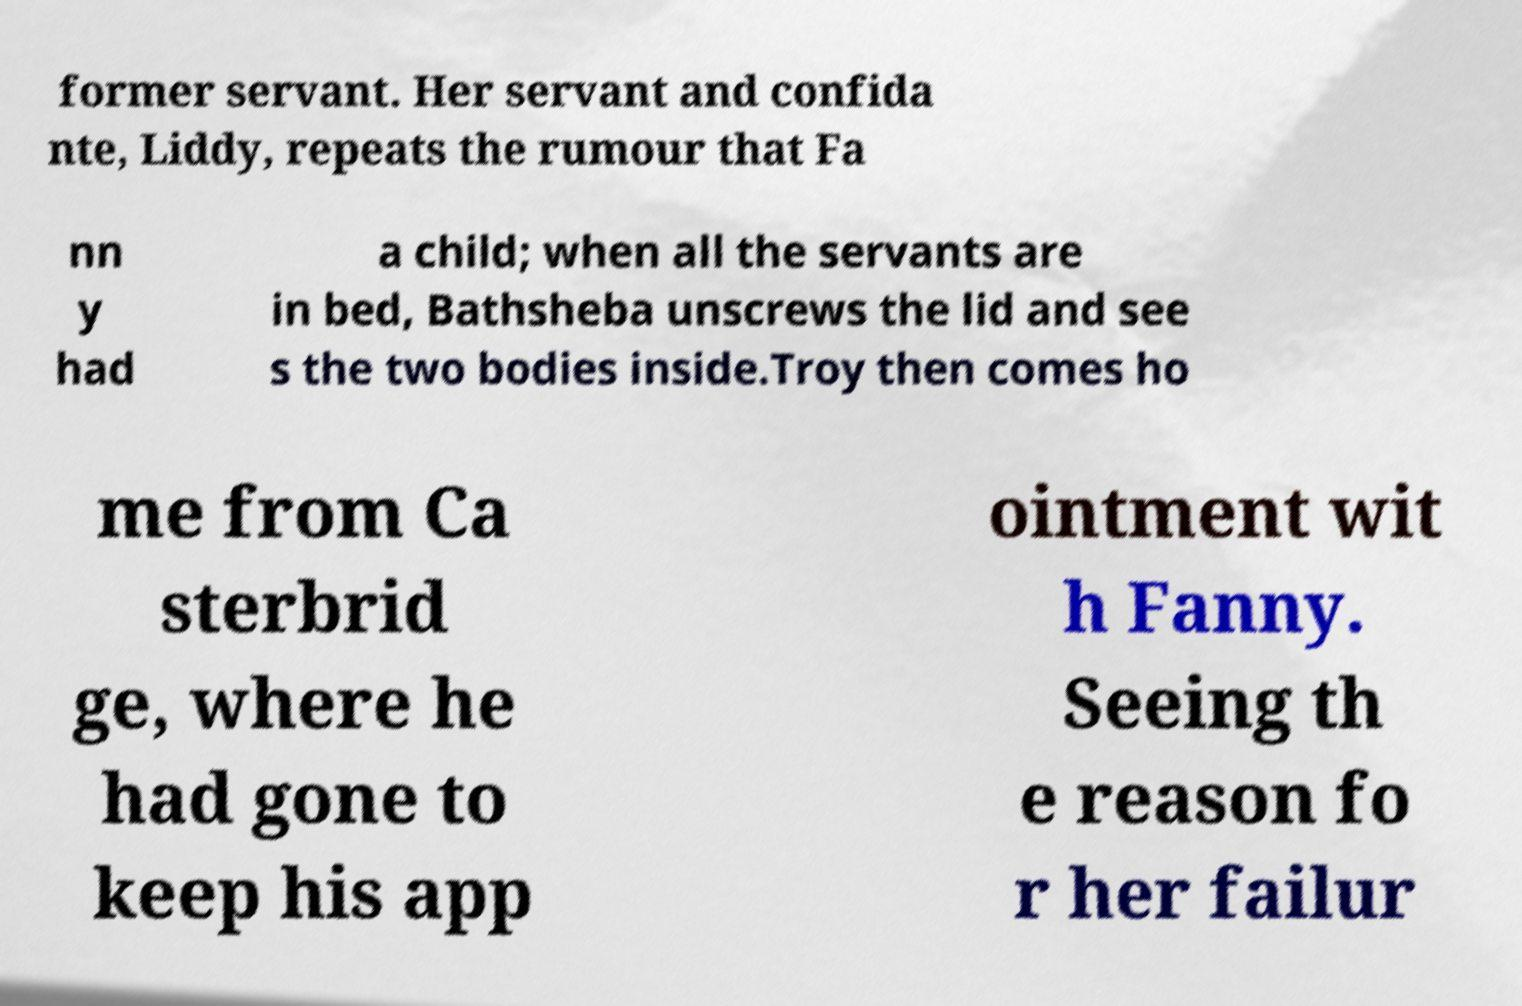Can you accurately transcribe the text from the provided image for me? former servant. Her servant and confida nte, Liddy, repeats the rumour that Fa nn y had a child; when all the servants are in bed, Bathsheba unscrews the lid and see s the two bodies inside.Troy then comes ho me from Ca sterbrid ge, where he had gone to keep his app ointment wit h Fanny. Seeing th e reason fo r her failur 